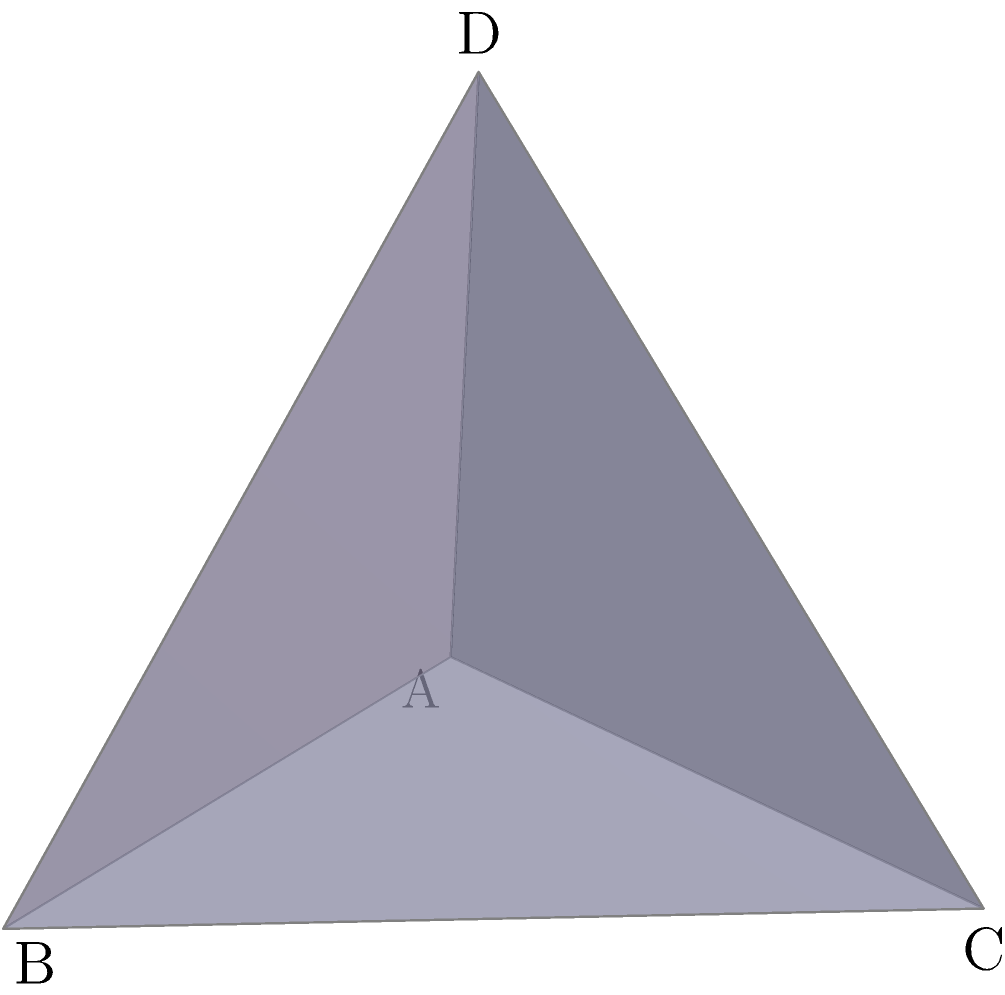In the context of edge computing and resource-constrained devices, efficient 3D modeling is crucial. Consider a regular tetrahedron ABCD as shown in the figure. What is the angle between any two faces of this tetrahedron? Express your answer in degrees, rounded to two decimal places. To find the angle between two faces of a regular tetrahedron, we can follow these steps:

1) In a regular tetrahedron, all faces are congruent equilateral triangles, and all dihedral angles (angles between faces) are equal.

2) Let's consider the angle between two adjacent faces, say ABC and ABD.

3) The dihedral angle is the angle between the normals of these two faces.

4) For a regular tetrahedron, we can use the following formula:

   $$\cos \theta = -\frac{1}{3}$$

   where $\theta$ is the dihedral angle.

5) To find $\theta$, we need to take the inverse cosine (arccos) of $-\frac{1}{3}$:

   $$\theta = \arccos(-\frac{1}{3})$$

6) Using a calculator or programming function:

   $$\theta \approx 1.9106332362490186 \text{ radians}$$

7) Convert to degrees:

   $$\theta \approx 1.9106332362490186 \times \frac{180}{\pi} \approx 109.47122063449069°$$

8) Rounding to two decimal places:

   $$\theta \approx 109.47°$$

This angle is a fundamental property of tetrahedral structures, which are common in many molecular and crystalline systems, making it relevant for researchers working on molecular modeling or materials science applications in edge computing environments.
Answer: 109.47° 